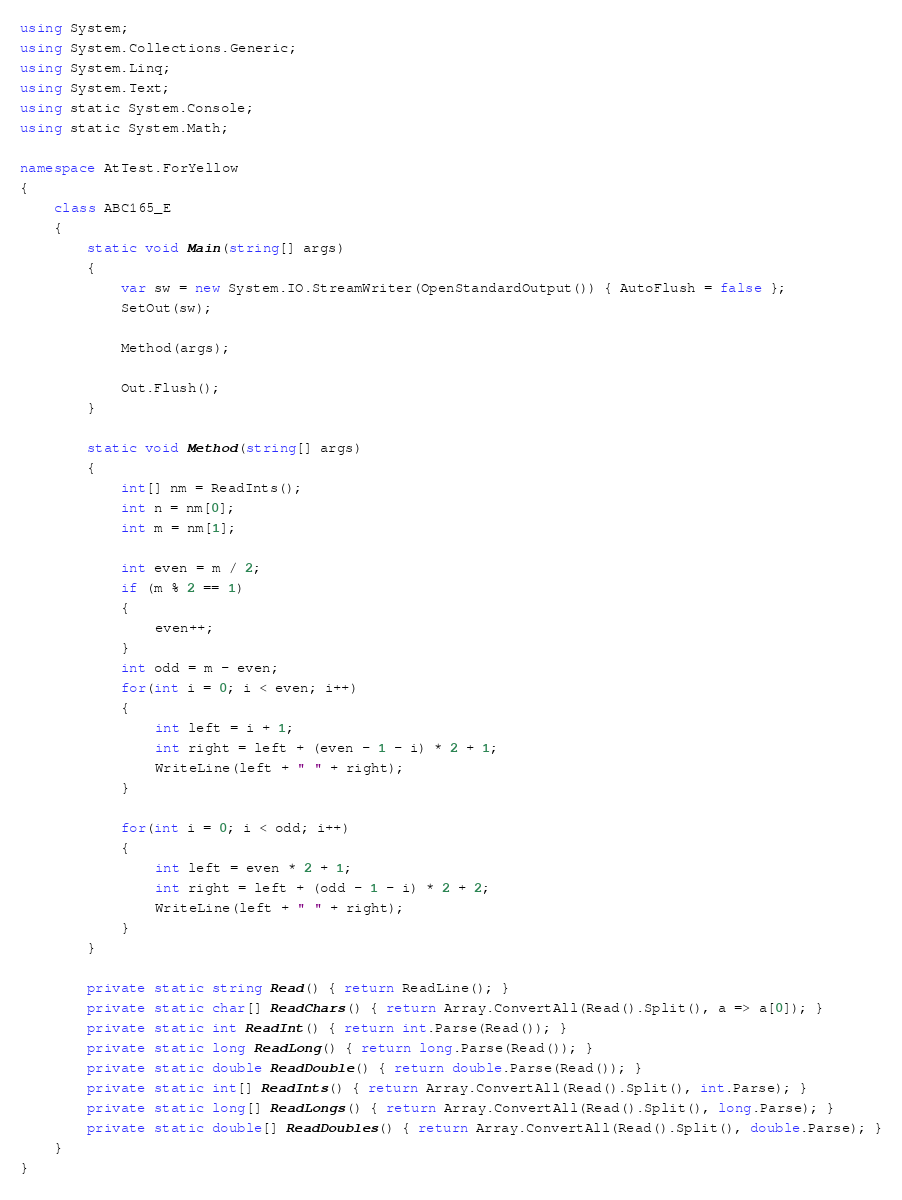<code> <loc_0><loc_0><loc_500><loc_500><_C#_>using System;
using System.Collections.Generic;
using System.Linq;
using System.Text;
using static System.Console;
using static System.Math;

namespace AtTest.ForYellow
{
    class ABC165_E
    {
        static void Main(string[] args)
        {
            var sw = new System.IO.StreamWriter(OpenStandardOutput()) { AutoFlush = false };
            SetOut(sw);

            Method(args);

            Out.Flush();
        }

        static void Method(string[] args)
        {
            int[] nm = ReadInts();
            int n = nm[0];
            int m = nm[1];

            int even = m / 2;
            if (m % 2 == 1)
            {
                even++;
            }
            int odd = m - even;
            for(int i = 0; i < even; i++)
            {
                int left = i + 1;
                int right = left + (even - 1 - i) * 2 + 1;
                WriteLine(left + " " + right);
            }

            for(int i = 0; i < odd; i++)
            {
                int left = even * 2 + 1;
                int right = left + (odd - 1 - i) * 2 + 2;
                WriteLine(left + " " + right);
            }
        }

        private static string Read() { return ReadLine(); }
        private static char[] ReadChars() { return Array.ConvertAll(Read().Split(), a => a[0]); }
        private static int ReadInt() { return int.Parse(Read()); }
        private static long ReadLong() { return long.Parse(Read()); }
        private static double ReadDouble() { return double.Parse(Read()); }
        private static int[] ReadInts() { return Array.ConvertAll(Read().Split(), int.Parse); }
        private static long[] ReadLongs() { return Array.ConvertAll(Read().Split(), long.Parse); }
        private static double[] ReadDoubles() { return Array.ConvertAll(Read().Split(), double.Parse); }
    }
}
</code> 